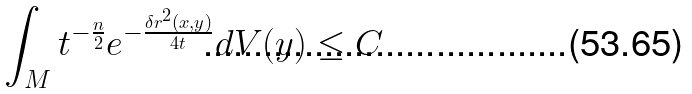Convert formula to latex. <formula><loc_0><loc_0><loc_500><loc_500>\int _ { M } t ^ { - \frac { n } { 2 } } e ^ { - \frac { \delta r ^ { 2 } ( x , y ) } { 4 t } } d V ( y ) \leq C</formula> 